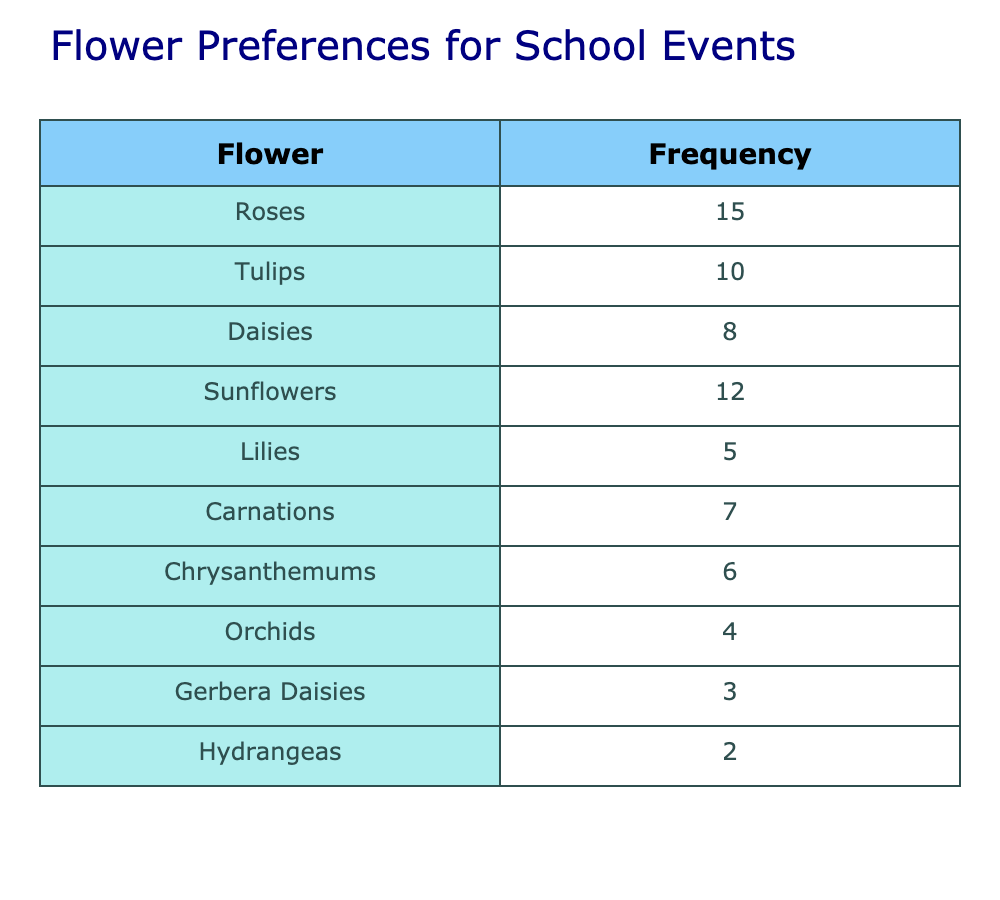What flower has the highest frequency? By looking at the table, we can see that the flower with the highest frequency is "Roses", which has a frequency of 15.
Answer: Roses What is the frequency of Sunflowers? The frequency of Sunflowers is listed in the table as 12.
Answer: 12 Are there more preferences for Tulips than for Lilies? The frequency of Tulips is 10, while the frequency of Lilies is 5. Since 10 is greater than 5, the answer is yes.
Answer: Yes What is the total frequency of all flowers listed? To find the total, we add up all the frequencies: 15 (Roses) + 10 (Tulips) + 8 (Daisies) + 12 (Sunflowers) + 5 (Lilies) + 7 (Carnations) + 6 (Chrysanthemums) + 4 (Orchids) + 3 (Gerbera Daisies) + 2 (Hydrangeas) = 72.
Answer: 72 Which flower has the least frequency? The flower with the least frequency in the table is "Hydrangeas", with a frequency of 2.
Answer: Hydrangeas What is the average frequency of the flowers? To find the average, we first calculate the total frequency which is 72 (from the previous question) and then divide it by the number of flower types, which is 10. So, 72 divided by 10 equals 7.2.
Answer: 7.2 Are there more preferences for Daisies or Carnations? The frequency of Daisies is 8, and the frequency of Carnations is 7. Since 8 is greater than 7, the answer is yes, there are more preferences for Daisies.
Answer: Yes How many flowers have a frequency of 6 or more? By checking the table, we find that the flowers with a frequency of 6 or more are: Roses (15), Sunflowers (12), Tulips (10), Daisies (8), Carnations (7), and Chrysanthemums (6). This makes a total of 6 flowers.
Answer: 6 What is the difference in frequency between Roses and Orchids? The frequency of Roses is 15 and the frequency of Orchids is 4. To find the difference, we subtract: 15 - 4 = 11.
Answer: 11 